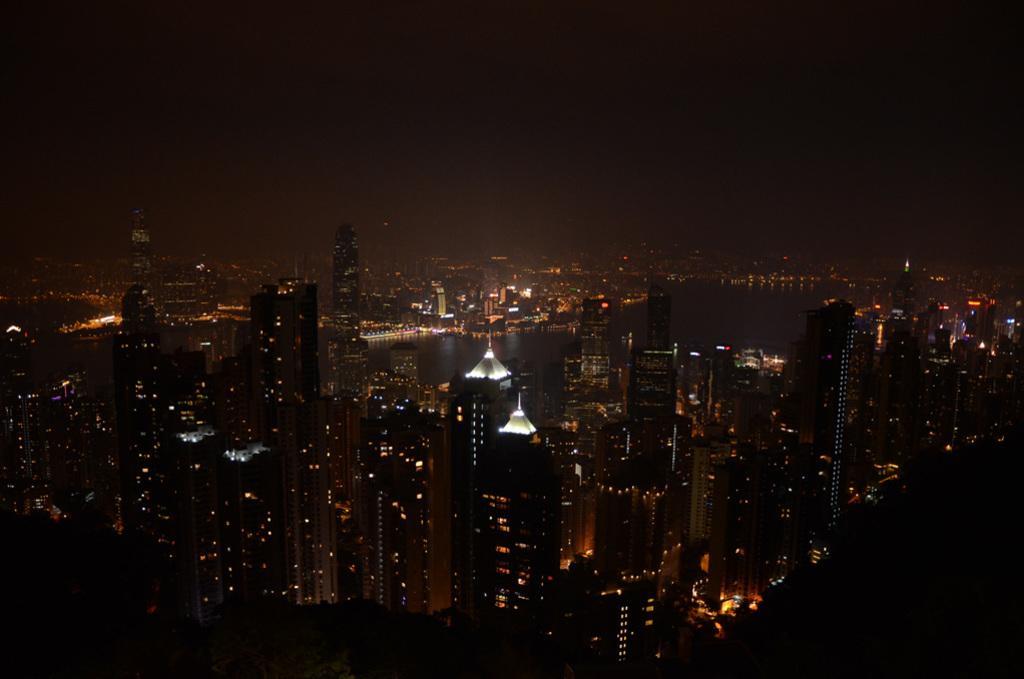Describe this image in one or two sentences. In this image, I can see the view of the city. These are the skyscrapers and buildings with the lights. I think this is the sky. 